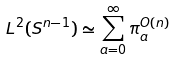Convert formula to latex. <formula><loc_0><loc_0><loc_500><loc_500>L ^ { 2 } ( S ^ { n - 1 } ) \simeq \sum _ { a = 0 } ^ { \infty } \pi ^ { O ( n ) } _ { a }</formula> 